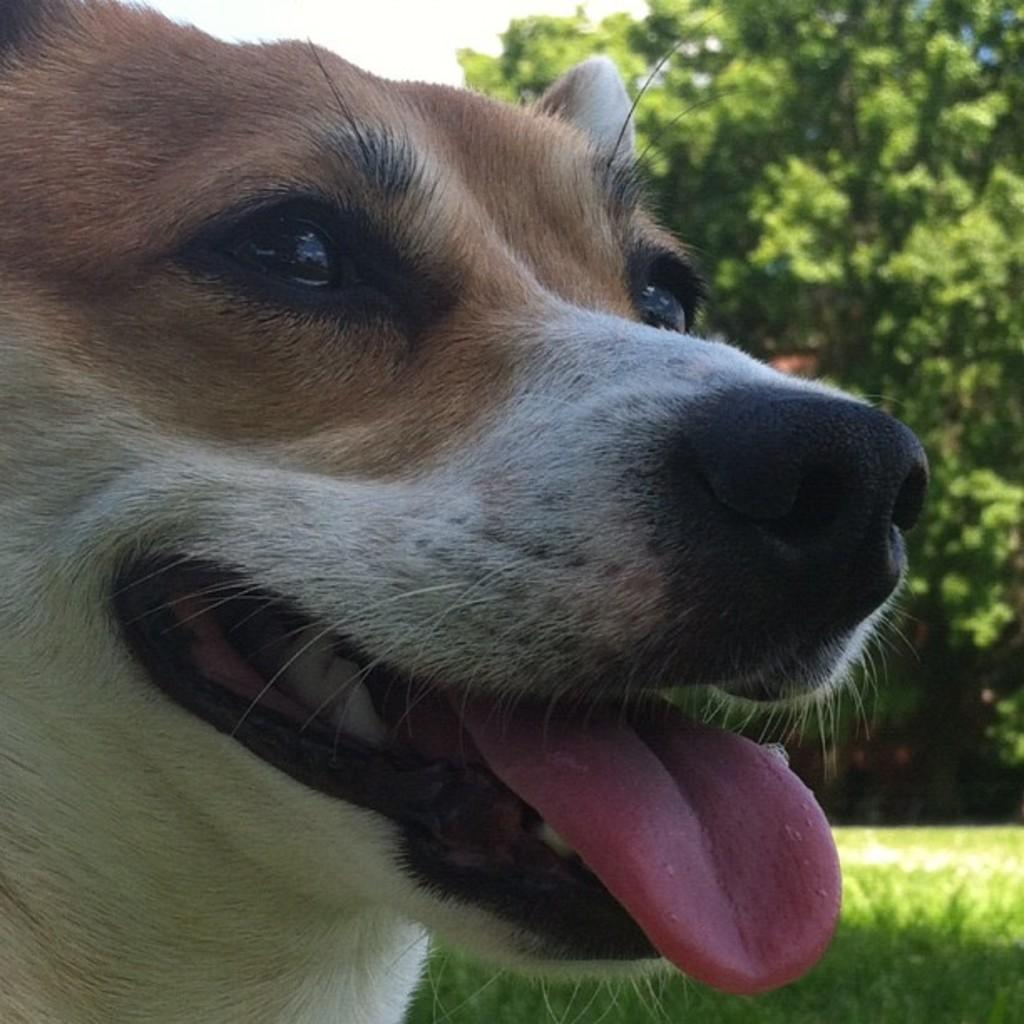What is the main subject of the image? There is a dog's face in the center of the image. What can be seen in the background of the image? There is grass, a tree, and the sky visible in the background of the image. Is the dog's tail visible in the image? The image only shows the dog's face, so the tail is not visible. Can you see any steam coming from the dog's mouth in the image? There is no steam present in the image. 